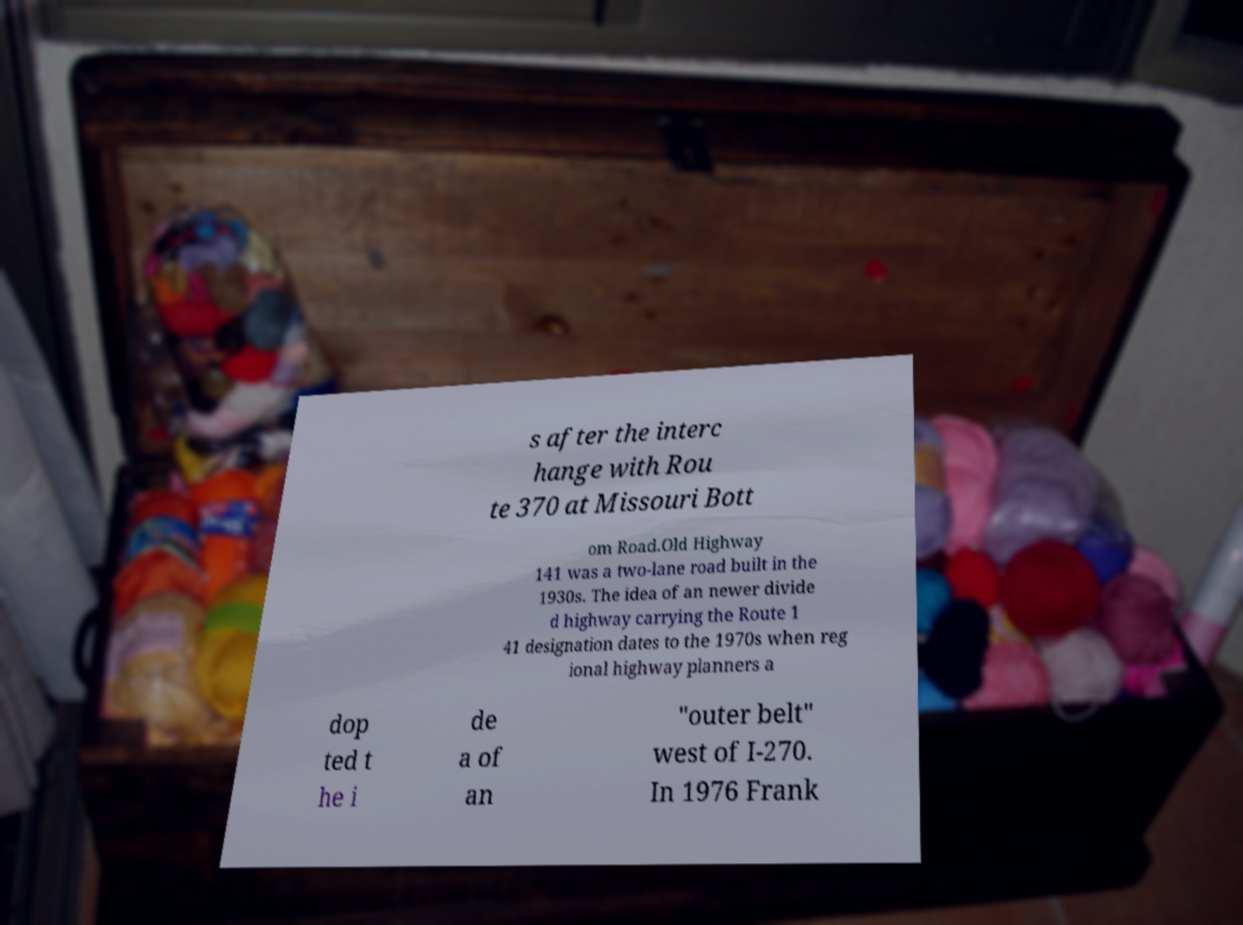Please read and relay the text visible in this image. What does it say? s after the interc hange with Rou te 370 at Missouri Bott om Road.Old Highway 141 was a two-lane road built in the 1930s. The idea of an newer divide d highway carrying the Route 1 41 designation dates to the 1970s when reg ional highway planners a dop ted t he i de a of an "outer belt" west of I-270. In 1976 Frank 